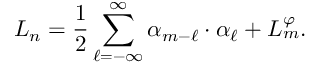<formula> <loc_0><loc_0><loc_500><loc_500>L _ { n } = { \frac { 1 } { 2 } } \sum _ { \ell = - \infty } ^ { \infty } \alpha _ { m - \ell } \cdot \alpha _ { \ell } + L _ { m } ^ { \varphi } .</formula> 